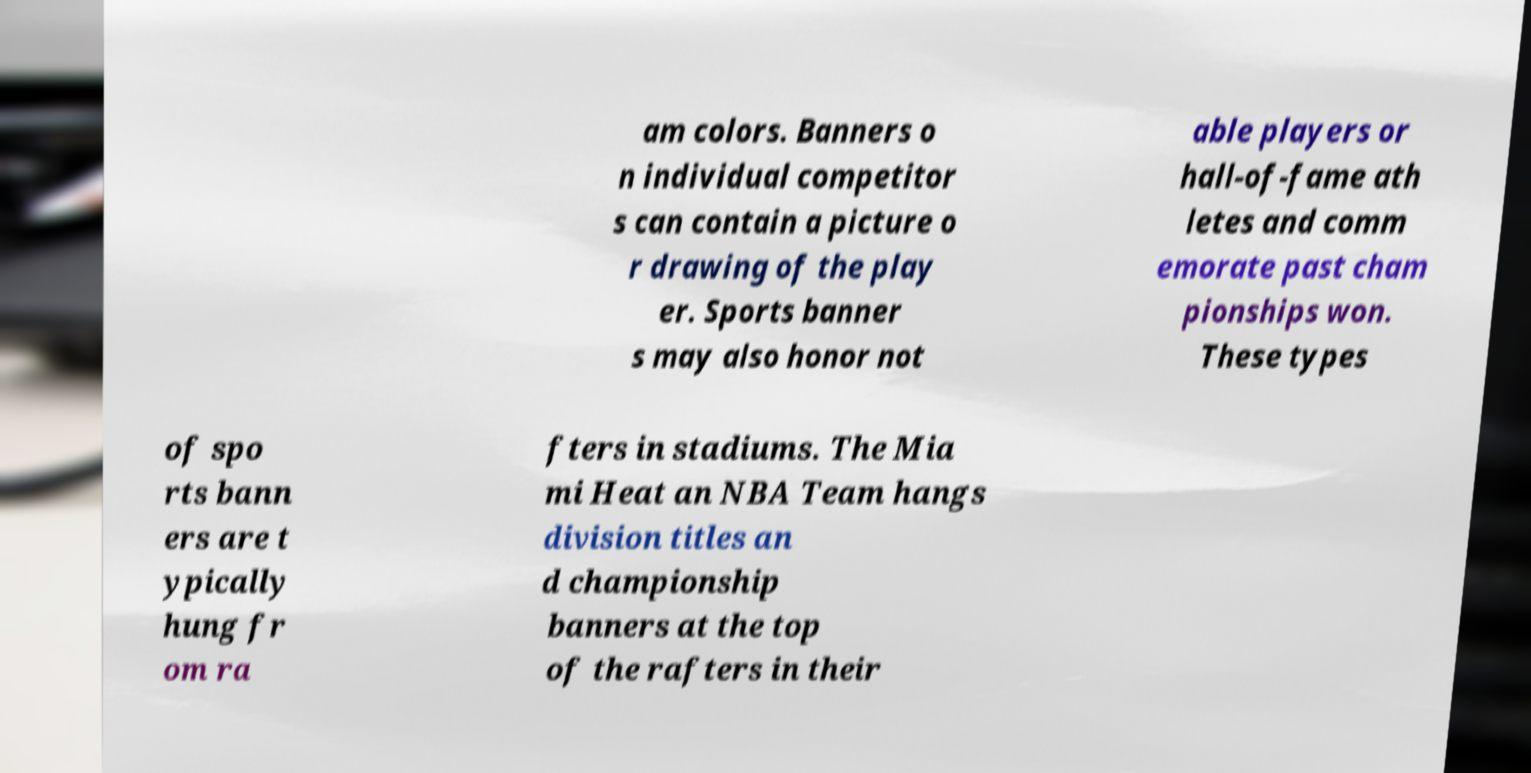Could you extract and type out the text from this image? am colors. Banners o n individual competitor s can contain a picture o r drawing of the play er. Sports banner s may also honor not able players or hall-of-fame ath letes and comm emorate past cham pionships won. These types of spo rts bann ers are t ypically hung fr om ra fters in stadiums. The Mia mi Heat an NBA Team hangs division titles an d championship banners at the top of the rafters in their 